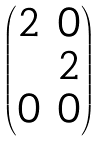Convert formula to latex. <formula><loc_0><loc_0><loc_500><loc_500>\begin{pmatrix} 2 & 0 \\ & 2 \\ 0 & 0 \end{pmatrix}</formula> 